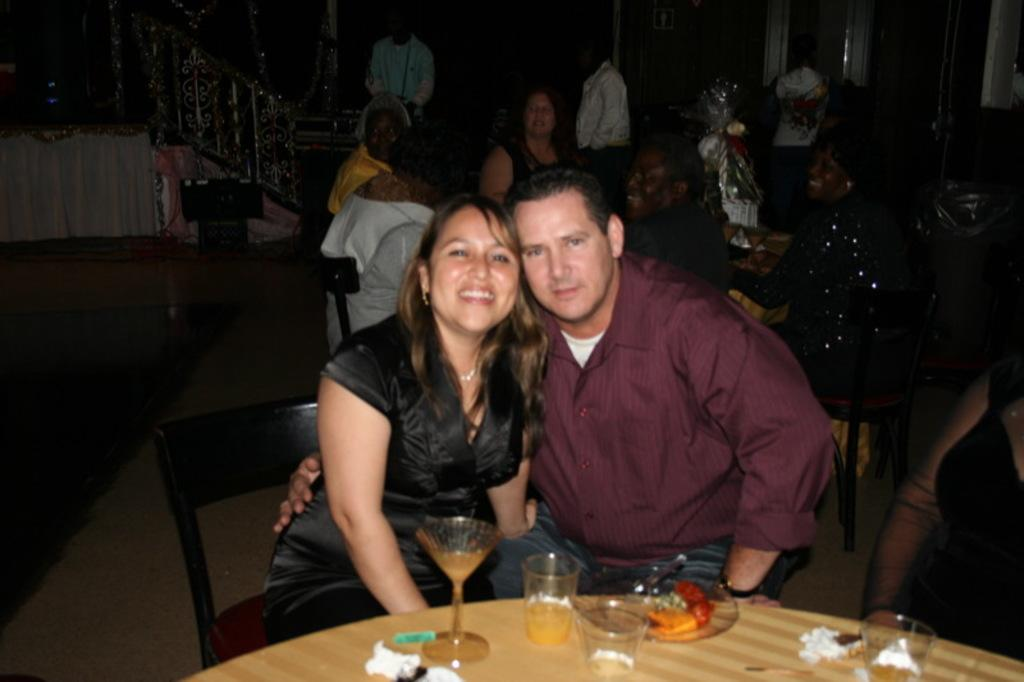How many people are sitting at the table in the image? There are two people sitting in front of the table in the image. What is on the table with the people? There is a plate and glasses on the table. What can be seen in the background of the image? There is a group of people and a railing in the background. Are there any waves or jellyfish visible in the image? No, there are no waves or jellyfish present in the image. Is there a basketball game taking place in the background? No, there is no basketball game visible in the image. 